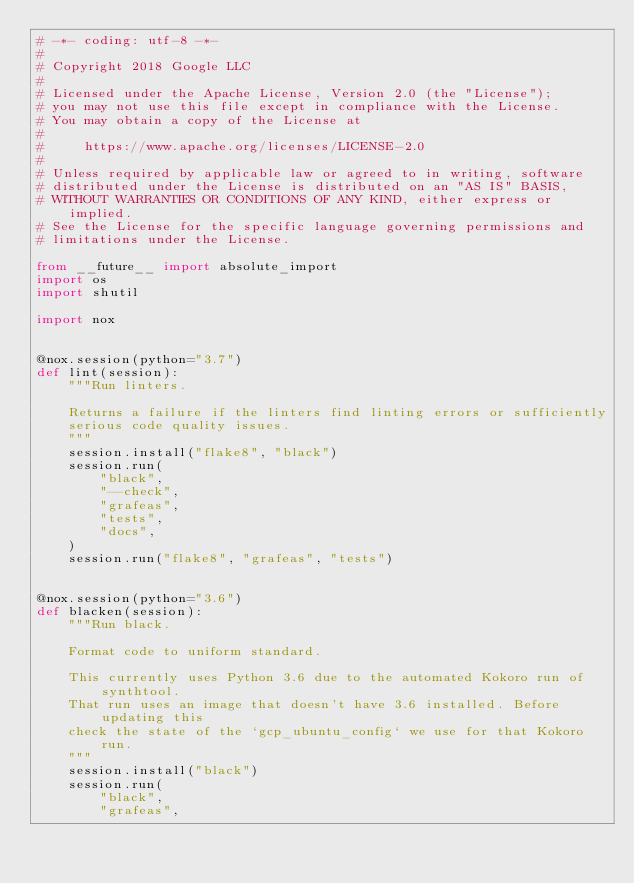Convert code to text. <code><loc_0><loc_0><loc_500><loc_500><_Python_># -*- coding: utf-8 -*-
#
# Copyright 2018 Google LLC
#
# Licensed under the Apache License, Version 2.0 (the "License");
# you may not use this file except in compliance with the License.
# You may obtain a copy of the License at
#
#     https://www.apache.org/licenses/LICENSE-2.0
#
# Unless required by applicable law or agreed to in writing, software
# distributed under the License is distributed on an "AS IS" BASIS,
# WITHOUT WARRANTIES OR CONDITIONS OF ANY KIND, either express or implied.
# See the License for the specific language governing permissions and
# limitations under the License.

from __future__ import absolute_import
import os
import shutil

import nox


@nox.session(python="3.7")
def lint(session):
    """Run linters.

    Returns a failure if the linters find linting errors or sufficiently
    serious code quality issues.
    """
    session.install("flake8", "black")
    session.run(
        "black",
        "--check",
        "grafeas",
        "tests",
        "docs",
    )
    session.run("flake8", "grafeas", "tests")


@nox.session(python="3.6")
def blacken(session):
    """Run black.

    Format code to uniform standard.
    
    This currently uses Python 3.6 due to the automated Kokoro run of synthtool.
    That run uses an image that doesn't have 3.6 installed. Before updating this
    check the state of the `gcp_ubuntu_config` we use for that Kokoro run.
    """
    session.install("black")
    session.run(
        "black",
        "grafeas",</code> 